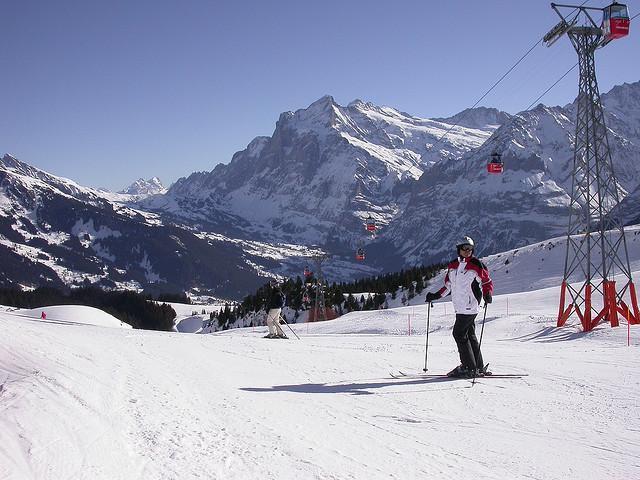Why are the bases of the towers brightly colored?
Pick the correct solution from the four options below to address the question.
Options: Sturdiness, sales boosting, safety visibility, marketing. Safety visibility. 